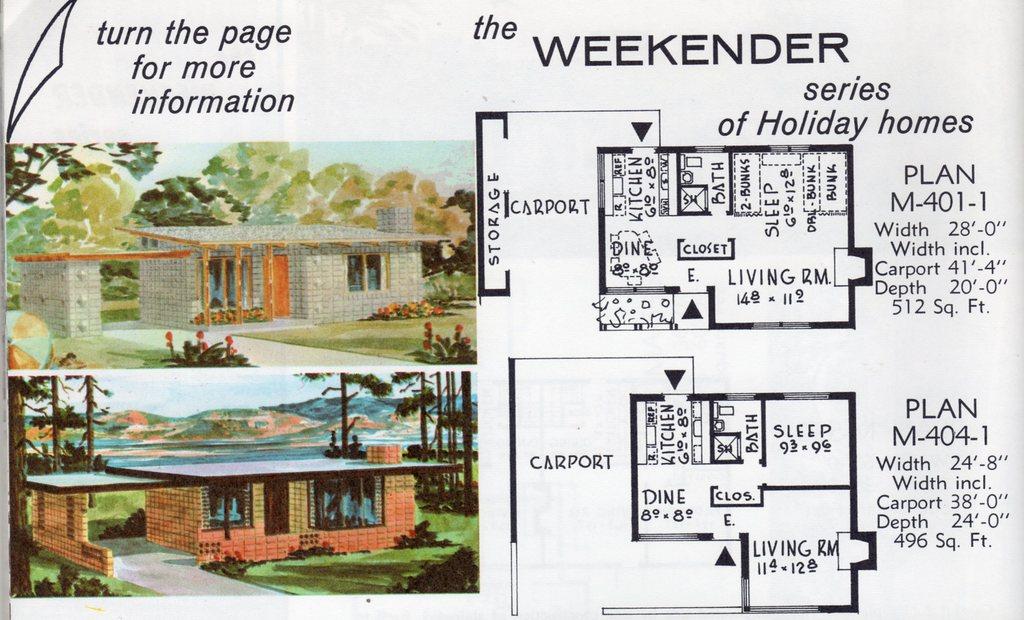What are the floor plans of?
Offer a terse response. Holiday homes. Is this for a new house?
Provide a short and direct response. Unanswerable. 